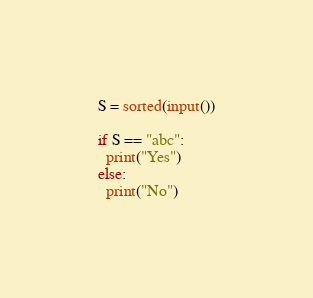<code> <loc_0><loc_0><loc_500><loc_500><_Python_>S = sorted(input())
 
if S == "abc":
  print("Yes")
else:
  print("No")</code> 